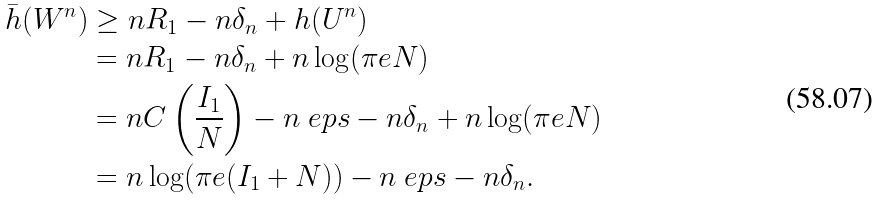<formula> <loc_0><loc_0><loc_500><loc_500>\bar { h } ( W ^ { n } ) & \geq n R _ { 1 } - n \delta _ { n } + h ( U ^ { n } ) \\ & = n R _ { 1 } - n \delta _ { n } + n \log ( \pi e N ) \\ & = n C \left ( \frac { I _ { 1 } } { N } \right ) - n \ e p s - n \delta _ { n } + n \log ( \pi e N ) \\ & = n \log ( \pi e ( I _ { 1 } + N ) ) - n \ e p s - n \delta _ { n } .</formula> 